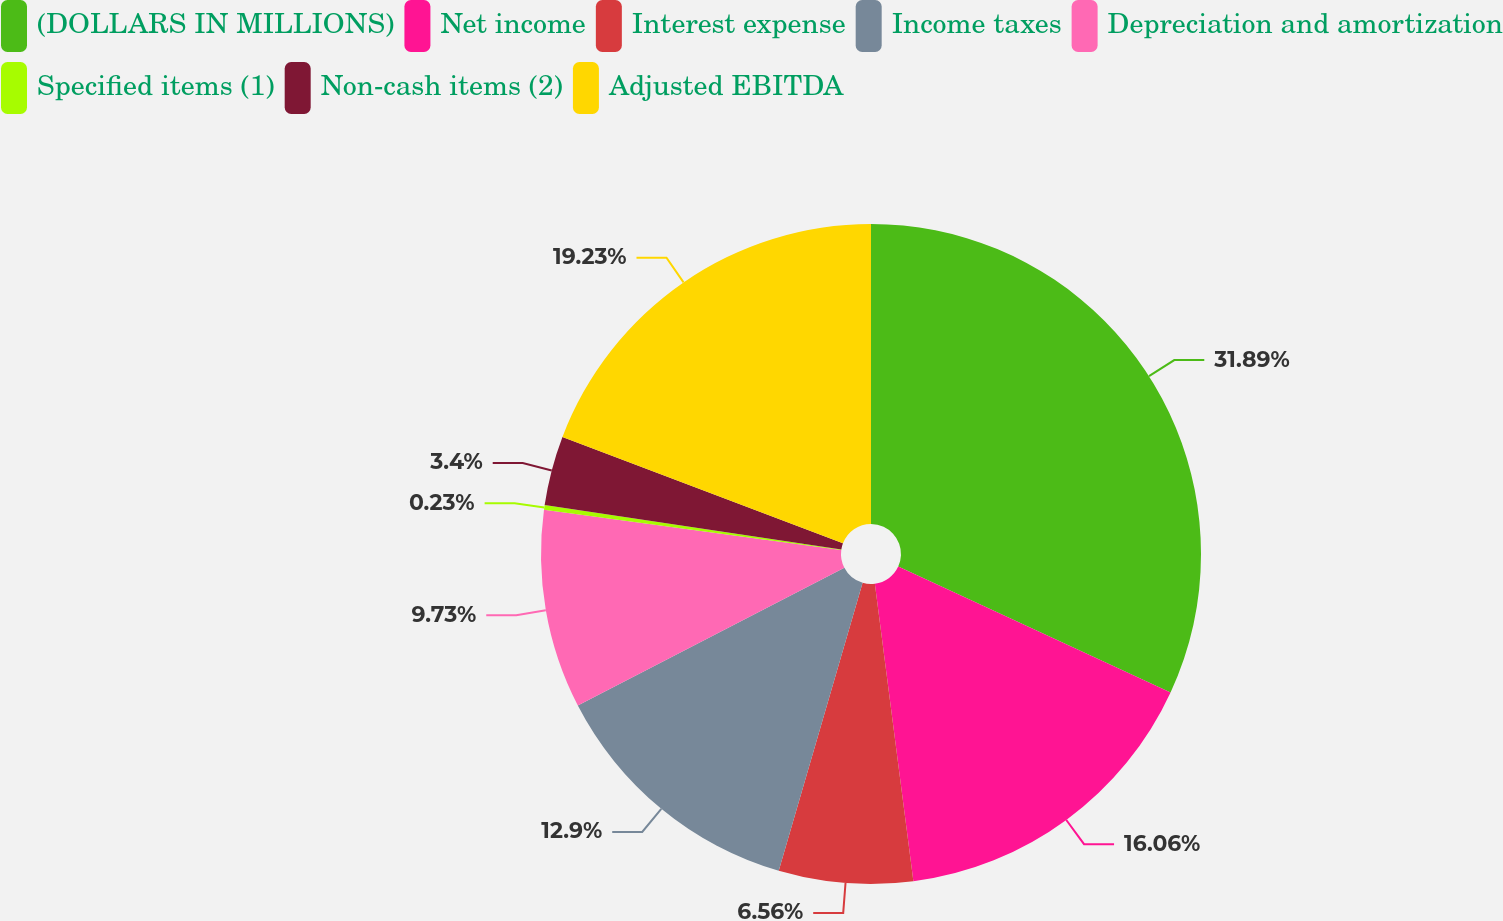Convert chart. <chart><loc_0><loc_0><loc_500><loc_500><pie_chart><fcel>(DOLLARS IN MILLIONS)<fcel>Net income<fcel>Interest expense<fcel>Income taxes<fcel>Depreciation and amortization<fcel>Specified items (1)<fcel>Non-cash items (2)<fcel>Adjusted EBITDA<nl><fcel>31.89%<fcel>16.06%<fcel>6.56%<fcel>12.9%<fcel>9.73%<fcel>0.23%<fcel>3.4%<fcel>19.23%<nl></chart> 